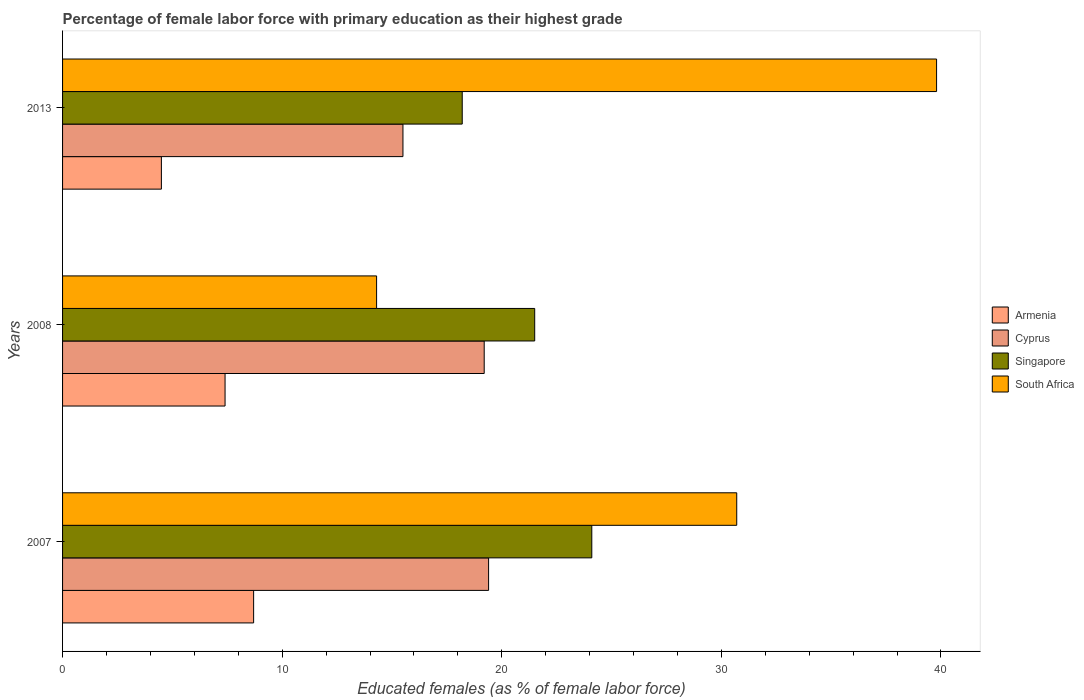How many bars are there on the 2nd tick from the top?
Offer a very short reply. 4. How many bars are there on the 2nd tick from the bottom?
Your answer should be very brief. 4. What is the percentage of female labor force with primary education in South Africa in 2008?
Your answer should be compact. 14.3. Across all years, what is the maximum percentage of female labor force with primary education in Singapore?
Keep it short and to the point. 24.1. Across all years, what is the minimum percentage of female labor force with primary education in Singapore?
Your response must be concise. 18.2. What is the total percentage of female labor force with primary education in Singapore in the graph?
Give a very brief answer. 63.8. What is the difference between the percentage of female labor force with primary education in Cyprus in 2007 and that in 2013?
Ensure brevity in your answer.  3.9. What is the difference between the percentage of female labor force with primary education in Singapore in 2008 and the percentage of female labor force with primary education in South Africa in 2013?
Offer a very short reply. -18.3. What is the average percentage of female labor force with primary education in Singapore per year?
Your answer should be very brief. 21.27. In the year 2008, what is the difference between the percentage of female labor force with primary education in Singapore and percentage of female labor force with primary education in Cyprus?
Provide a short and direct response. 2.3. In how many years, is the percentage of female labor force with primary education in South Africa greater than 28 %?
Your answer should be very brief. 2. What is the ratio of the percentage of female labor force with primary education in Cyprus in 2007 to that in 2008?
Offer a very short reply. 1.01. Is the percentage of female labor force with primary education in Armenia in 2007 less than that in 2008?
Your response must be concise. No. What is the difference between the highest and the second highest percentage of female labor force with primary education in Singapore?
Make the answer very short. 2.6. What is the difference between the highest and the lowest percentage of female labor force with primary education in Armenia?
Your answer should be very brief. 4.2. In how many years, is the percentage of female labor force with primary education in South Africa greater than the average percentage of female labor force with primary education in South Africa taken over all years?
Keep it short and to the point. 2. Is the sum of the percentage of female labor force with primary education in Singapore in 2007 and 2013 greater than the maximum percentage of female labor force with primary education in Cyprus across all years?
Give a very brief answer. Yes. What does the 2nd bar from the top in 2013 represents?
Give a very brief answer. Singapore. What does the 2nd bar from the bottom in 2007 represents?
Your answer should be compact. Cyprus. Are all the bars in the graph horizontal?
Offer a terse response. Yes. What is the difference between two consecutive major ticks on the X-axis?
Provide a succinct answer. 10. Where does the legend appear in the graph?
Provide a short and direct response. Center right. How are the legend labels stacked?
Your answer should be compact. Vertical. What is the title of the graph?
Your answer should be very brief. Percentage of female labor force with primary education as their highest grade. Does "Serbia" appear as one of the legend labels in the graph?
Give a very brief answer. No. What is the label or title of the X-axis?
Keep it short and to the point. Educated females (as % of female labor force). What is the label or title of the Y-axis?
Your answer should be very brief. Years. What is the Educated females (as % of female labor force) of Armenia in 2007?
Keep it short and to the point. 8.7. What is the Educated females (as % of female labor force) of Cyprus in 2007?
Provide a succinct answer. 19.4. What is the Educated females (as % of female labor force) in Singapore in 2007?
Provide a short and direct response. 24.1. What is the Educated females (as % of female labor force) in South Africa in 2007?
Keep it short and to the point. 30.7. What is the Educated females (as % of female labor force) in Armenia in 2008?
Offer a terse response. 7.4. What is the Educated females (as % of female labor force) in Cyprus in 2008?
Make the answer very short. 19.2. What is the Educated females (as % of female labor force) in South Africa in 2008?
Provide a succinct answer. 14.3. What is the Educated females (as % of female labor force) in Armenia in 2013?
Provide a short and direct response. 4.5. What is the Educated females (as % of female labor force) of Singapore in 2013?
Provide a succinct answer. 18.2. What is the Educated females (as % of female labor force) of South Africa in 2013?
Provide a short and direct response. 39.8. Across all years, what is the maximum Educated females (as % of female labor force) of Armenia?
Your answer should be very brief. 8.7. Across all years, what is the maximum Educated females (as % of female labor force) of Cyprus?
Provide a succinct answer. 19.4. Across all years, what is the maximum Educated females (as % of female labor force) of Singapore?
Your response must be concise. 24.1. Across all years, what is the maximum Educated females (as % of female labor force) in South Africa?
Provide a succinct answer. 39.8. Across all years, what is the minimum Educated females (as % of female labor force) in Armenia?
Ensure brevity in your answer.  4.5. Across all years, what is the minimum Educated females (as % of female labor force) in Cyprus?
Make the answer very short. 15.5. Across all years, what is the minimum Educated females (as % of female labor force) in Singapore?
Offer a very short reply. 18.2. Across all years, what is the minimum Educated females (as % of female labor force) in South Africa?
Your response must be concise. 14.3. What is the total Educated females (as % of female labor force) of Armenia in the graph?
Your answer should be compact. 20.6. What is the total Educated females (as % of female labor force) of Cyprus in the graph?
Ensure brevity in your answer.  54.1. What is the total Educated females (as % of female labor force) of Singapore in the graph?
Keep it short and to the point. 63.8. What is the total Educated females (as % of female labor force) of South Africa in the graph?
Provide a short and direct response. 84.8. What is the difference between the Educated females (as % of female labor force) of Cyprus in 2007 and that in 2008?
Your answer should be compact. 0.2. What is the difference between the Educated females (as % of female labor force) of South Africa in 2007 and that in 2008?
Your response must be concise. 16.4. What is the difference between the Educated females (as % of female labor force) of Armenia in 2007 and that in 2013?
Offer a very short reply. 4.2. What is the difference between the Educated females (as % of female labor force) in Cyprus in 2007 and that in 2013?
Make the answer very short. 3.9. What is the difference between the Educated females (as % of female labor force) of South Africa in 2007 and that in 2013?
Make the answer very short. -9.1. What is the difference between the Educated females (as % of female labor force) in Armenia in 2008 and that in 2013?
Provide a succinct answer. 2.9. What is the difference between the Educated females (as % of female labor force) in Singapore in 2008 and that in 2013?
Your response must be concise. 3.3. What is the difference between the Educated females (as % of female labor force) in South Africa in 2008 and that in 2013?
Your response must be concise. -25.5. What is the difference between the Educated females (as % of female labor force) of Armenia in 2007 and the Educated females (as % of female labor force) of Cyprus in 2008?
Offer a very short reply. -10.5. What is the difference between the Educated females (as % of female labor force) of Armenia in 2007 and the Educated females (as % of female labor force) of Singapore in 2008?
Keep it short and to the point. -12.8. What is the difference between the Educated females (as % of female labor force) of Cyprus in 2007 and the Educated females (as % of female labor force) of Singapore in 2008?
Your response must be concise. -2.1. What is the difference between the Educated females (as % of female labor force) of Cyprus in 2007 and the Educated females (as % of female labor force) of South Africa in 2008?
Give a very brief answer. 5.1. What is the difference between the Educated females (as % of female labor force) in Singapore in 2007 and the Educated females (as % of female labor force) in South Africa in 2008?
Keep it short and to the point. 9.8. What is the difference between the Educated females (as % of female labor force) of Armenia in 2007 and the Educated females (as % of female labor force) of Cyprus in 2013?
Keep it short and to the point. -6.8. What is the difference between the Educated females (as % of female labor force) in Armenia in 2007 and the Educated females (as % of female labor force) in Singapore in 2013?
Make the answer very short. -9.5. What is the difference between the Educated females (as % of female labor force) of Armenia in 2007 and the Educated females (as % of female labor force) of South Africa in 2013?
Your answer should be compact. -31.1. What is the difference between the Educated females (as % of female labor force) of Cyprus in 2007 and the Educated females (as % of female labor force) of Singapore in 2013?
Make the answer very short. 1.2. What is the difference between the Educated females (as % of female labor force) of Cyprus in 2007 and the Educated females (as % of female labor force) of South Africa in 2013?
Your answer should be very brief. -20.4. What is the difference between the Educated females (as % of female labor force) in Singapore in 2007 and the Educated females (as % of female labor force) in South Africa in 2013?
Provide a succinct answer. -15.7. What is the difference between the Educated females (as % of female labor force) in Armenia in 2008 and the Educated females (as % of female labor force) in South Africa in 2013?
Offer a very short reply. -32.4. What is the difference between the Educated females (as % of female labor force) in Cyprus in 2008 and the Educated females (as % of female labor force) in Singapore in 2013?
Your answer should be compact. 1. What is the difference between the Educated females (as % of female labor force) of Cyprus in 2008 and the Educated females (as % of female labor force) of South Africa in 2013?
Offer a terse response. -20.6. What is the difference between the Educated females (as % of female labor force) in Singapore in 2008 and the Educated females (as % of female labor force) in South Africa in 2013?
Offer a terse response. -18.3. What is the average Educated females (as % of female labor force) of Armenia per year?
Your answer should be compact. 6.87. What is the average Educated females (as % of female labor force) of Cyprus per year?
Your response must be concise. 18.03. What is the average Educated females (as % of female labor force) of Singapore per year?
Make the answer very short. 21.27. What is the average Educated females (as % of female labor force) in South Africa per year?
Make the answer very short. 28.27. In the year 2007, what is the difference between the Educated females (as % of female labor force) of Armenia and Educated females (as % of female labor force) of Cyprus?
Keep it short and to the point. -10.7. In the year 2007, what is the difference between the Educated females (as % of female labor force) of Armenia and Educated females (as % of female labor force) of Singapore?
Your response must be concise. -15.4. In the year 2007, what is the difference between the Educated females (as % of female labor force) of Cyprus and Educated females (as % of female labor force) of South Africa?
Your answer should be very brief. -11.3. In the year 2007, what is the difference between the Educated females (as % of female labor force) in Singapore and Educated females (as % of female labor force) in South Africa?
Your answer should be very brief. -6.6. In the year 2008, what is the difference between the Educated females (as % of female labor force) in Armenia and Educated females (as % of female labor force) in Singapore?
Keep it short and to the point. -14.1. In the year 2008, what is the difference between the Educated females (as % of female labor force) in Armenia and Educated females (as % of female labor force) in South Africa?
Provide a succinct answer. -6.9. In the year 2013, what is the difference between the Educated females (as % of female labor force) in Armenia and Educated females (as % of female labor force) in Singapore?
Your response must be concise. -13.7. In the year 2013, what is the difference between the Educated females (as % of female labor force) of Armenia and Educated females (as % of female labor force) of South Africa?
Offer a very short reply. -35.3. In the year 2013, what is the difference between the Educated females (as % of female labor force) of Cyprus and Educated females (as % of female labor force) of South Africa?
Your answer should be very brief. -24.3. In the year 2013, what is the difference between the Educated females (as % of female labor force) in Singapore and Educated females (as % of female labor force) in South Africa?
Offer a very short reply. -21.6. What is the ratio of the Educated females (as % of female labor force) of Armenia in 2007 to that in 2008?
Provide a short and direct response. 1.18. What is the ratio of the Educated females (as % of female labor force) of Cyprus in 2007 to that in 2008?
Provide a succinct answer. 1.01. What is the ratio of the Educated females (as % of female labor force) in Singapore in 2007 to that in 2008?
Offer a very short reply. 1.12. What is the ratio of the Educated females (as % of female labor force) in South Africa in 2007 to that in 2008?
Offer a terse response. 2.15. What is the ratio of the Educated females (as % of female labor force) of Armenia in 2007 to that in 2013?
Provide a short and direct response. 1.93. What is the ratio of the Educated females (as % of female labor force) of Cyprus in 2007 to that in 2013?
Give a very brief answer. 1.25. What is the ratio of the Educated females (as % of female labor force) of Singapore in 2007 to that in 2013?
Give a very brief answer. 1.32. What is the ratio of the Educated females (as % of female labor force) of South Africa in 2007 to that in 2013?
Give a very brief answer. 0.77. What is the ratio of the Educated females (as % of female labor force) of Armenia in 2008 to that in 2013?
Keep it short and to the point. 1.64. What is the ratio of the Educated females (as % of female labor force) in Cyprus in 2008 to that in 2013?
Ensure brevity in your answer.  1.24. What is the ratio of the Educated females (as % of female labor force) in Singapore in 2008 to that in 2013?
Your answer should be very brief. 1.18. What is the ratio of the Educated females (as % of female labor force) in South Africa in 2008 to that in 2013?
Give a very brief answer. 0.36. What is the difference between the highest and the second highest Educated females (as % of female labor force) of Armenia?
Offer a very short reply. 1.3. What is the difference between the highest and the second highest Educated females (as % of female labor force) of Cyprus?
Your answer should be very brief. 0.2. What is the difference between the highest and the second highest Educated females (as % of female labor force) of South Africa?
Your response must be concise. 9.1. What is the difference between the highest and the lowest Educated females (as % of female labor force) in Singapore?
Provide a short and direct response. 5.9. 